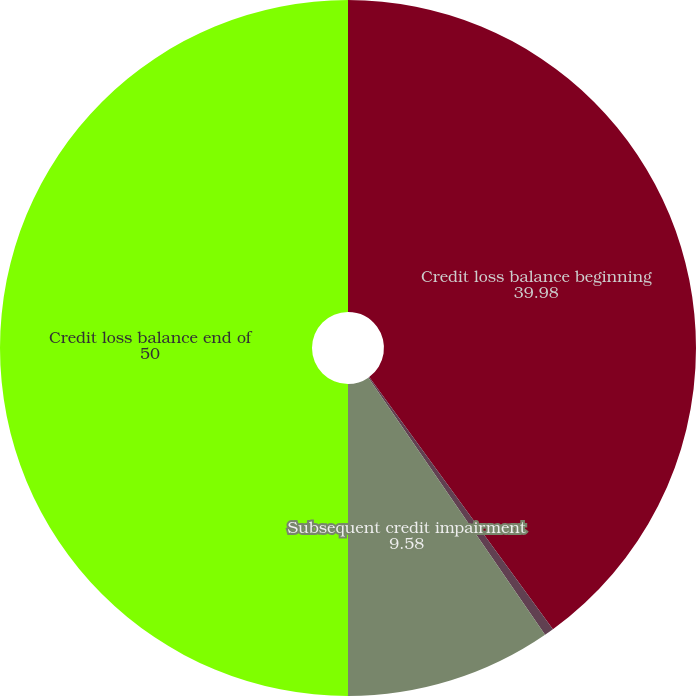Convert chart. <chart><loc_0><loc_0><loc_500><loc_500><pie_chart><fcel>Credit loss balance beginning<fcel>Initial credit impairment<fcel>Subsequent credit impairment<fcel>Credit loss balance end of<nl><fcel>39.98%<fcel>0.44%<fcel>9.58%<fcel>50.0%<nl></chart> 